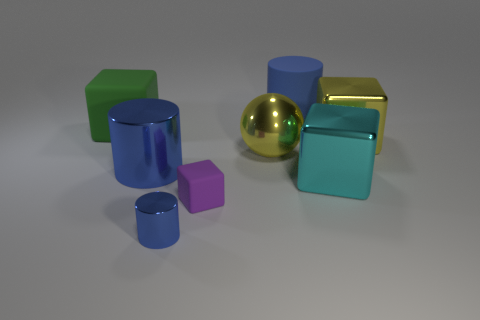The purple object has what shape? cube 